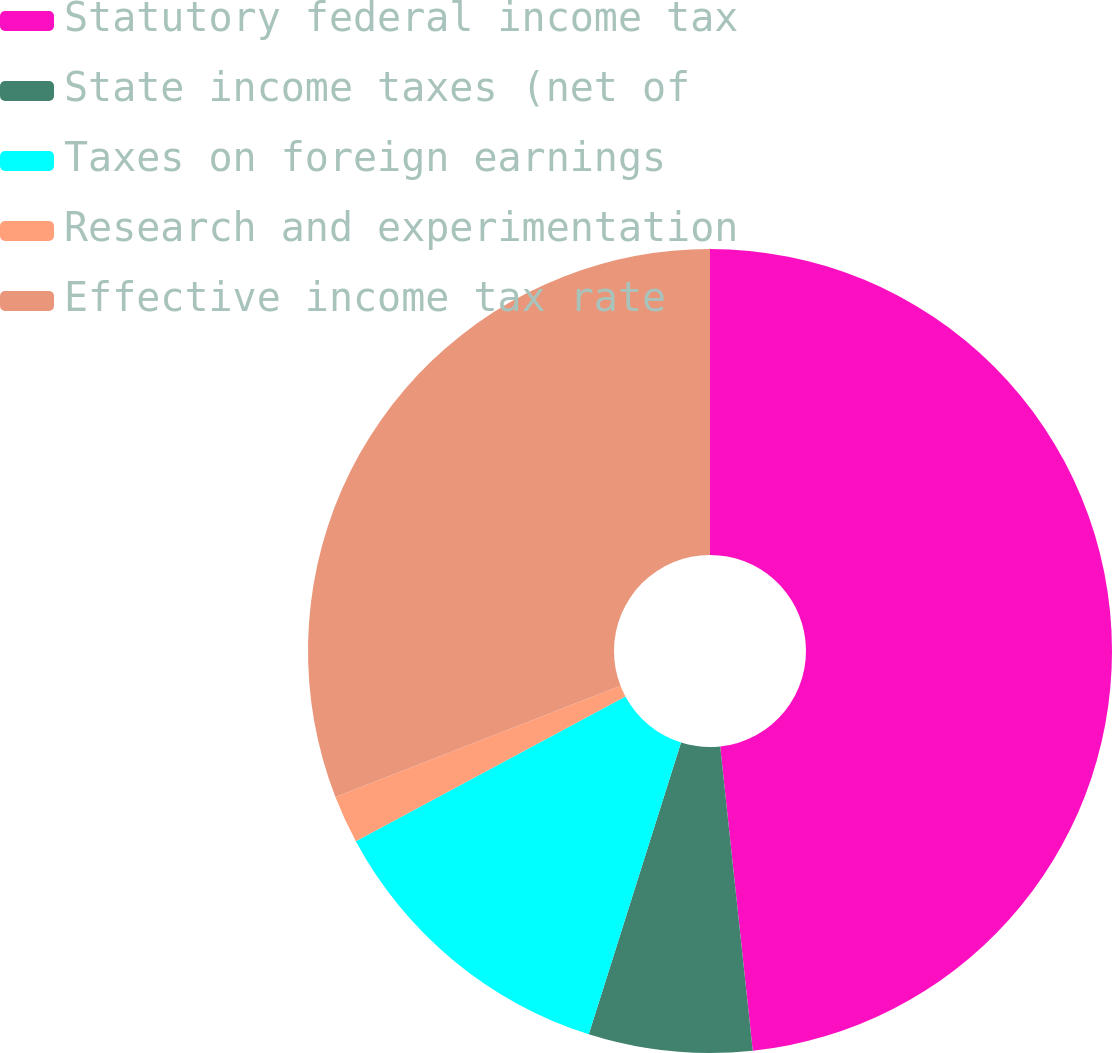Convert chart. <chart><loc_0><loc_0><loc_500><loc_500><pie_chart><fcel>Statutory federal income tax<fcel>State income taxes (net of<fcel>Taxes on foreign earnings<fcel>Research and experimentation<fcel>Effective income tax rate<nl><fcel>48.3%<fcel>6.57%<fcel>12.28%<fcel>1.93%<fcel>30.91%<nl></chart> 